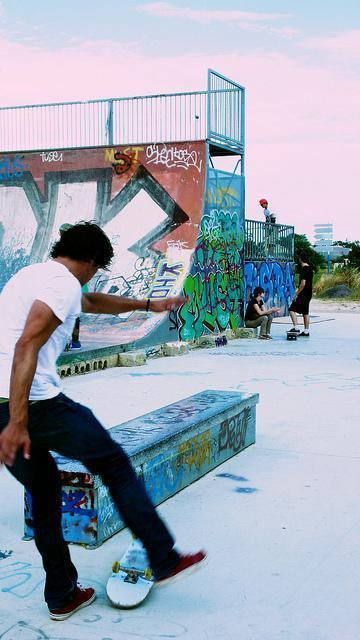What is the large ramp used for?
Answer the question by selecting the correct answer among the 4 following choices.
Options: Basketball, skateboarding, football, sledding. Skateboarding. 